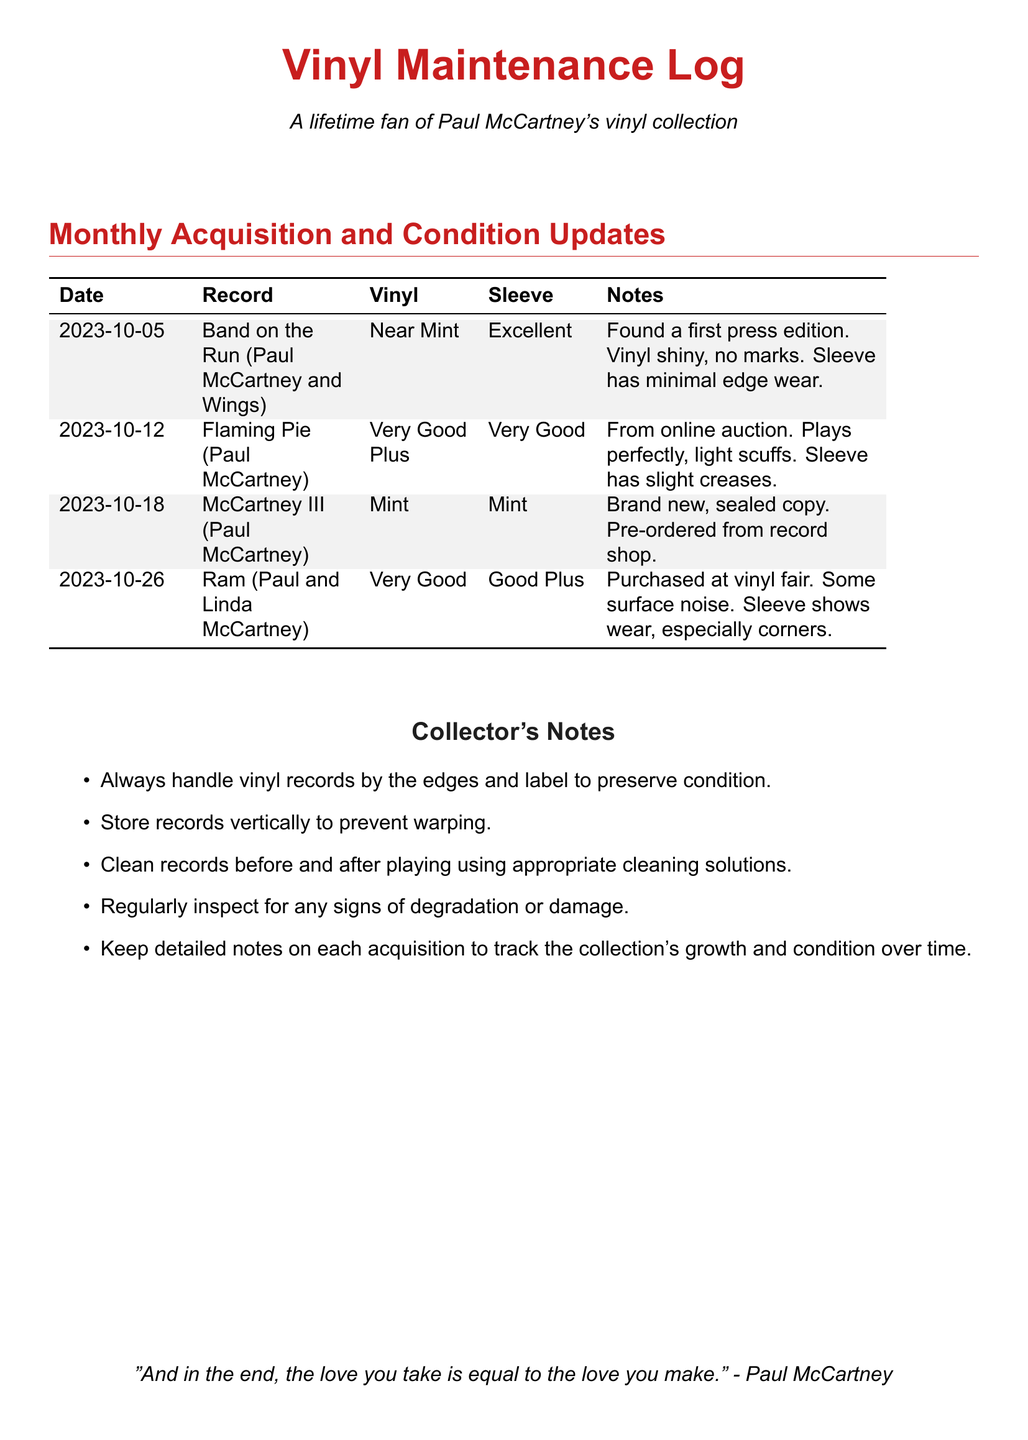what is the title of the first record listed? The first record listed under the acquisition section is titled "Band on the Run (Paul McCartney and Wings)."
Answer: Band on the Run (Paul McCartney and Wings) what was the condition of "McCartney III"? The condition of "McCartney III" is described as Mint for both the vinyl and sleeve.
Answer: Mint which record has the least favorable sleeve condition? The record with the least favorable sleeve condition is "Ram," which has a condition of Good Plus.
Answer: Ram how many records were acquired on October 12th, 2023? There was one record acquired on October 12th, 2023, which is "Flaming Pie (Paul McCartney)."
Answer: One what notes were recorded for "Flaming Pie"? The notes for "Flaming Pie" state "From online auction. Plays perfectly, light scuffs. Sleeve has slight creases."
Answer: From online auction. Plays perfectly, light scuffs. Sleeve has slight creases what is the date of the last entry in the log? The last entry in the log is dated October 26th, 2023.
Answer: October 26th, 2023 how did the collector acquire "McCartney III"? "McCartney III" was pre-ordered from a record shop, and it is a brand new, sealed copy.
Answer: Pre-ordered from record shop what cleaning advice is given for handling records? The advice given is to "Clean records before and after playing using appropriate cleaning solutions."
Answer: Clean records before and after playing using appropriate cleaning solutions 